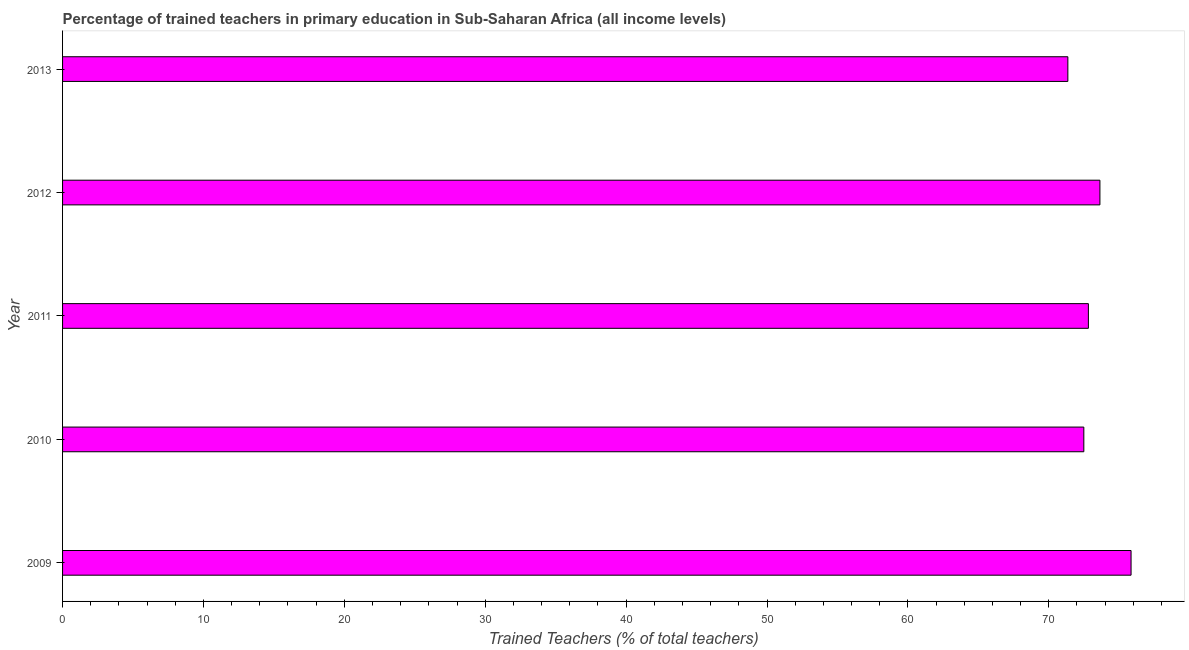What is the title of the graph?
Ensure brevity in your answer.  Percentage of trained teachers in primary education in Sub-Saharan Africa (all income levels). What is the label or title of the X-axis?
Provide a short and direct response. Trained Teachers (% of total teachers). What is the percentage of trained teachers in 2011?
Ensure brevity in your answer.  72.81. Across all years, what is the maximum percentage of trained teachers?
Offer a terse response. 75.84. Across all years, what is the minimum percentage of trained teachers?
Make the answer very short. 71.35. In which year was the percentage of trained teachers minimum?
Offer a terse response. 2013. What is the sum of the percentage of trained teachers?
Keep it short and to the point. 366.12. What is the difference between the percentage of trained teachers in 2012 and 2013?
Make the answer very short. 2.27. What is the average percentage of trained teachers per year?
Your response must be concise. 73.22. What is the median percentage of trained teachers?
Give a very brief answer. 72.81. In how many years, is the percentage of trained teachers greater than 36 %?
Ensure brevity in your answer.  5. Do a majority of the years between 2009 and 2010 (inclusive) have percentage of trained teachers greater than 58 %?
Offer a very short reply. Yes. What is the ratio of the percentage of trained teachers in 2011 to that in 2013?
Ensure brevity in your answer.  1.02. What is the difference between the highest and the second highest percentage of trained teachers?
Your response must be concise. 2.21. What is the difference between the highest and the lowest percentage of trained teachers?
Your response must be concise. 4.49. How many bars are there?
Provide a succinct answer. 5. How many years are there in the graph?
Your answer should be compact. 5. What is the difference between two consecutive major ticks on the X-axis?
Provide a succinct answer. 10. What is the Trained Teachers (% of total teachers) of 2009?
Offer a terse response. 75.84. What is the Trained Teachers (% of total teachers) of 2010?
Provide a succinct answer. 72.49. What is the Trained Teachers (% of total teachers) of 2011?
Make the answer very short. 72.81. What is the Trained Teachers (% of total teachers) of 2012?
Your response must be concise. 73.63. What is the Trained Teachers (% of total teachers) in 2013?
Your answer should be very brief. 71.35. What is the difference between the Trained Teachers (% of total teachers) in 2009 and 2010?
Provide a succinct answer. 3.35. What is the difference between the Trained Teachers (% of total teachers) in 2009 and 2011?
Keep it short and to the point. 3.03. What is the difference between the Trained Teachers (% of total teachers) in 2009 and 2012?
Your answer should be very brief. 2.21. What is the difference between the Trained Teachers (% of total teachers) in 2009 and 2013?
Your answer should be compact. 4.49. What is the difference between the Trained Teachers (% of total teachers) in 2010 and 2011?
Offer a very short reply. -0.32. What is the difference between the Trained Teachers (% of total teachers) in 2010 and 2012?
Your answer should be compact. -1.14. What is the difference between the Trained Teachers (% of total teachers) in 2010 and 2013?
Provide a short and direct response. 1.13. What is the difference between the Trained Teachers (% of total teachers) in 2011 and 2012?
Offer a terse response. -0.82. What is the difference between the Trained Teachers (% of total teachers) in 2011 and 2013?
Your answer should be very brief. 1.46. What is the difference between the Trained Teachers (% of total teachers) in 2012 and 2013?
Your answer should be very brief. 2.28. What is the ratio of the Trained Teachers (% of total teachers) in 2009 to that in 2010?
Keep it short and to the point. 1.05. What is the ratio of the Trained Teachers (% of total teachers) in 2009 to that in 2011?
Ensure brevity in your answer.  1.04. What is the ratio of the Trained Teachers (% of total teachers) in 2009 to that in 2012?
Your answer should be compact. 1.03. What is the ratio of the Trained Teachers (% of total teachers) in 2009 to that in 2013?
Your answer should be very brief. 1.06. What is the ratio of the Trained Teachers (% of total teachers) in 2010 to that in 2012?
Your answer should be compact. 0.98. What is the ratio of the Trained Teachers (% of total teachers) in 2010 to that in 2013?
Keep it short and to the point. 1.02. What is the ratio of the Trained Teachers (% of total teachers) in 2012 to that in 2013?
Your answer should be compact. 1.03. 